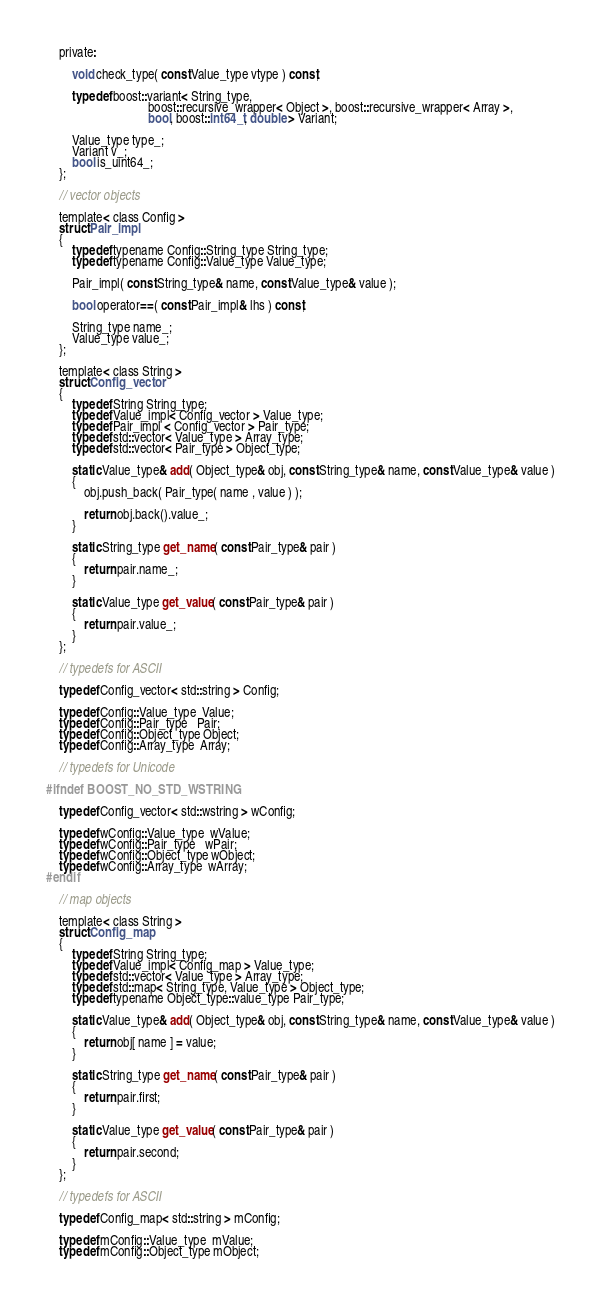Convert code to text. <code><loc_0><loc_0><loc_500><loc_500><_C_>
    private:

        void check_type( const Value_type vtype ) const;

        typedef boost::variant< String_type, 
                                boost::recursive_wrapper< Object >, boost::recursive_wrapper< Array >, 
                                bool, boost::int64_t, double > Variant;

        Value_type type_;
        Variant v_;
        bool is_uint64_;
    };

    // vector objects

    template< class Config >
    struct Pair_impl
    {
        typedef typename Config::String_type String_type;
        typedef typename Config::Value_type Value_type;

        Pair_impl( const String_type& name, const Value_type& value );

        bool operator==( const Pair_impl& lhs ) const;

        String_type name_;
        Value_type value_;
    };

    template< class String >
    struct Config_vector
    {
        typedef String String_type;
        typedef Value_impl< Config_vector > Value_type;
        typedef Pair_impl < Config_vector > Pair_type;
        typedef std::vector< Value_type > Array_type;
        typedef std::vector< Pair_type > Object_type;

        static Value_type& add( Object_type& obj, const String_type& name, const Value_type& value )
        {
            obj.push_back( Pair_type( name , value ) );

            return obj.back().value_;
        }
                
        static String_type get_name( const Pair_type& pair )
        {
            return pair.name_;
        }
                
        static Value_type get_value( const Pair_type& pair )
        {
            return pair.value_;
        }
    };

    // typedefs for ASCII

    typedef Config_vector< std::string > Config;

    typedef Config::Value_type  Value;
    typedef Config::Pair_type   Pair;
    typedef Config::Object_type Object;
    typedef Config::Array_type  Array;

    // typedefs for Unicode

#ifndef BOOST_NO_STD_WSTRING

    typedef Config_vector< std::wstring > wConfig;

    typedef wConfig::Value_type  wValue;
    typedef wConfig::Pair_type   wPair;
    typedef wConfig::Object_type wObject;
    typedef wConfig::Array_type  wArray;
#endif

    // map objects

    template< class String >
    struct Config_map
    {
        typedef String String_type;
        typedef Value_impl< Config_map > Value_type;
        typedef std::vector< Value_type > Array_type;
        typedef std::map< String_type, Value_type > Object_type;
        typedef typename Object_type::value_type Pair_type;

        static Value_type& add( Object_type& obj, const String_type& name, const Value_type& value )
        {
            return obj[ name ] = value;
        }
                
        static String_type get_name( const Pair_type& pair )
        {
            return pair.first;
        }
                
        static Value_type get_value( const Pair_type& pair )
        {
            return pair.second;
        }
    };

    // typedefs for ASCII

    typedef Config_map< std::string > mConfig;

    typedef mConfig::Value_type  mValue;
    typedef mConfig::Object_type mObject;</code> 